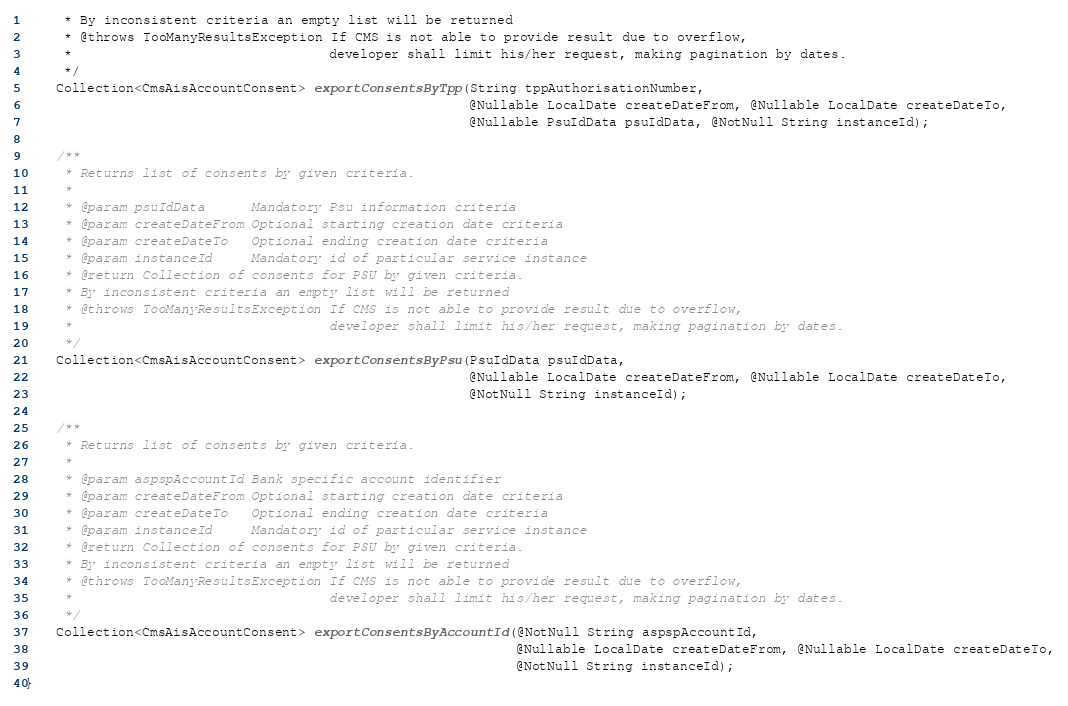<code> <loc_0><loc_0><loc_500><loc_500><_Java_>     * By inconsistent criteria an empty list will be returned
     * @throws TooManyResultsException If CMS is not able to provide result due to overflow,
     *                                 developer shall limit his/her request, making pagination by dates.
     */
    Collection<CmsAisAccountConsent> exportConsentsByTpp(String tppAuthorisationNumber,
                                                         @Nullable LocalDate createDateFrom, @Nullable LocalDate createDateTo,
                                                         @Nullable PsuIdData psuIdData, @NotNull String instanceId);

    /**
     * Returns list of consents by given criteria.
     *
     * @param psuIdData      Mandatory Psu information criteria
     * @param createDateFrom Optional starting creation date criteria
     * @param createDateTo   Optional ending creation date criteria
     * @param instanceId     Mandatory id of particular service instance
     * @return Collection of consents for PSU by given criteria.
     * By inconsistent criteria an empty list will be returned
     * @throws TooManyResultsException If CMS is not able to provide result due to overflow,
     *                                 developer shall limit his/her request, making pagination by dates.
     */
    Collection<CmsAisAccountConsent> exportConsentsByPsu(PsuIdData psuIdData,
                                                         @Nullable LocalDate createDateFrom, @Nullable LocalDate createDateTo,
                                                         @NotNull String instanceId);

    /**
     * Returns list of consents by given criteria.
     *
     * @param aspspAccountId Bank specific account identifier
     * @param createDateFrom Optional starting creation date criteria
     * @param createDateTo   Optional ending creation date criteria
     * @param instanceId     Mandatory id of particular service instance
     * @return Collection of consents for PSU by given criteria.
     * By inconsistent criteria an empty list will be returned
     * @throws TooManyResultsException If CMS is not able to provide result due to overflow,
     *                                 developer shall limit his/her request, making pagination by dates.
     */
    Collection<CmsAisAccountConsent> exportConsentsByAccountId(@NotNull String aspspAccountId,
                                                               @Nullable LocalDate createDateFrom, @Nullable LocalDate createDateTo,
                                                               @NotNull String instanceId);
}
</code> 